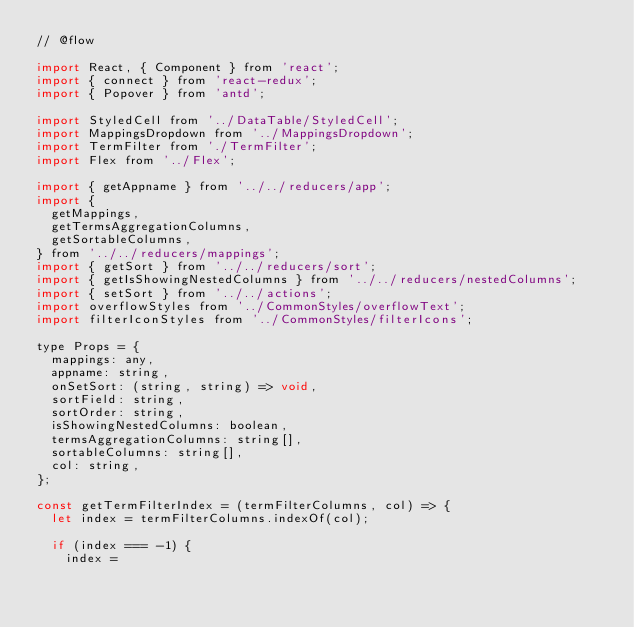<code> <loc_0><loc_0><loc_500><loc_500><_JavaScript_>// @flow

import React, { Component } from 'react';
import { connect } from 'react-redux';
import { Popover } from 'antd';

import StyledCell from '../DataTable/StyledCell';
import MappingsDropdown from '../MappingsDropdown';
import TermFilter from './TermFilter';
import Flex from '../Flex';

import { getAppname } from '../../reducers/app';
import {
	getMappings,
	getTermsAggregationColumns,
	getSortableColumns,
} from '../../reducers/mappings';
import { getSort } from '../../reducers/sort';
import { getIsShowingNestedColumns } from '../../reducers/nestedColumns';
import { setSort } from '../../actions';
import overflowStyles from '../CommonStyles/overflowText';
import filterIconStyles from '../CommonStyles/filterIcons';

type Props = {
	mappings: any,
	appname: string,
	onSetSort: (string, string) => void,
	sortField: string,
	sortOrder: string,
	isShowingNestedColumns: boolean,
	termsAggregationColumns: string[],
	sortableColumns: string[],
	col: string,
};

const getTermFilterIndex = (termFilterColumns, col) => {
	let index = termFilterColumns.indexOf(col);

	if (index === -1) {
		index =</code> 